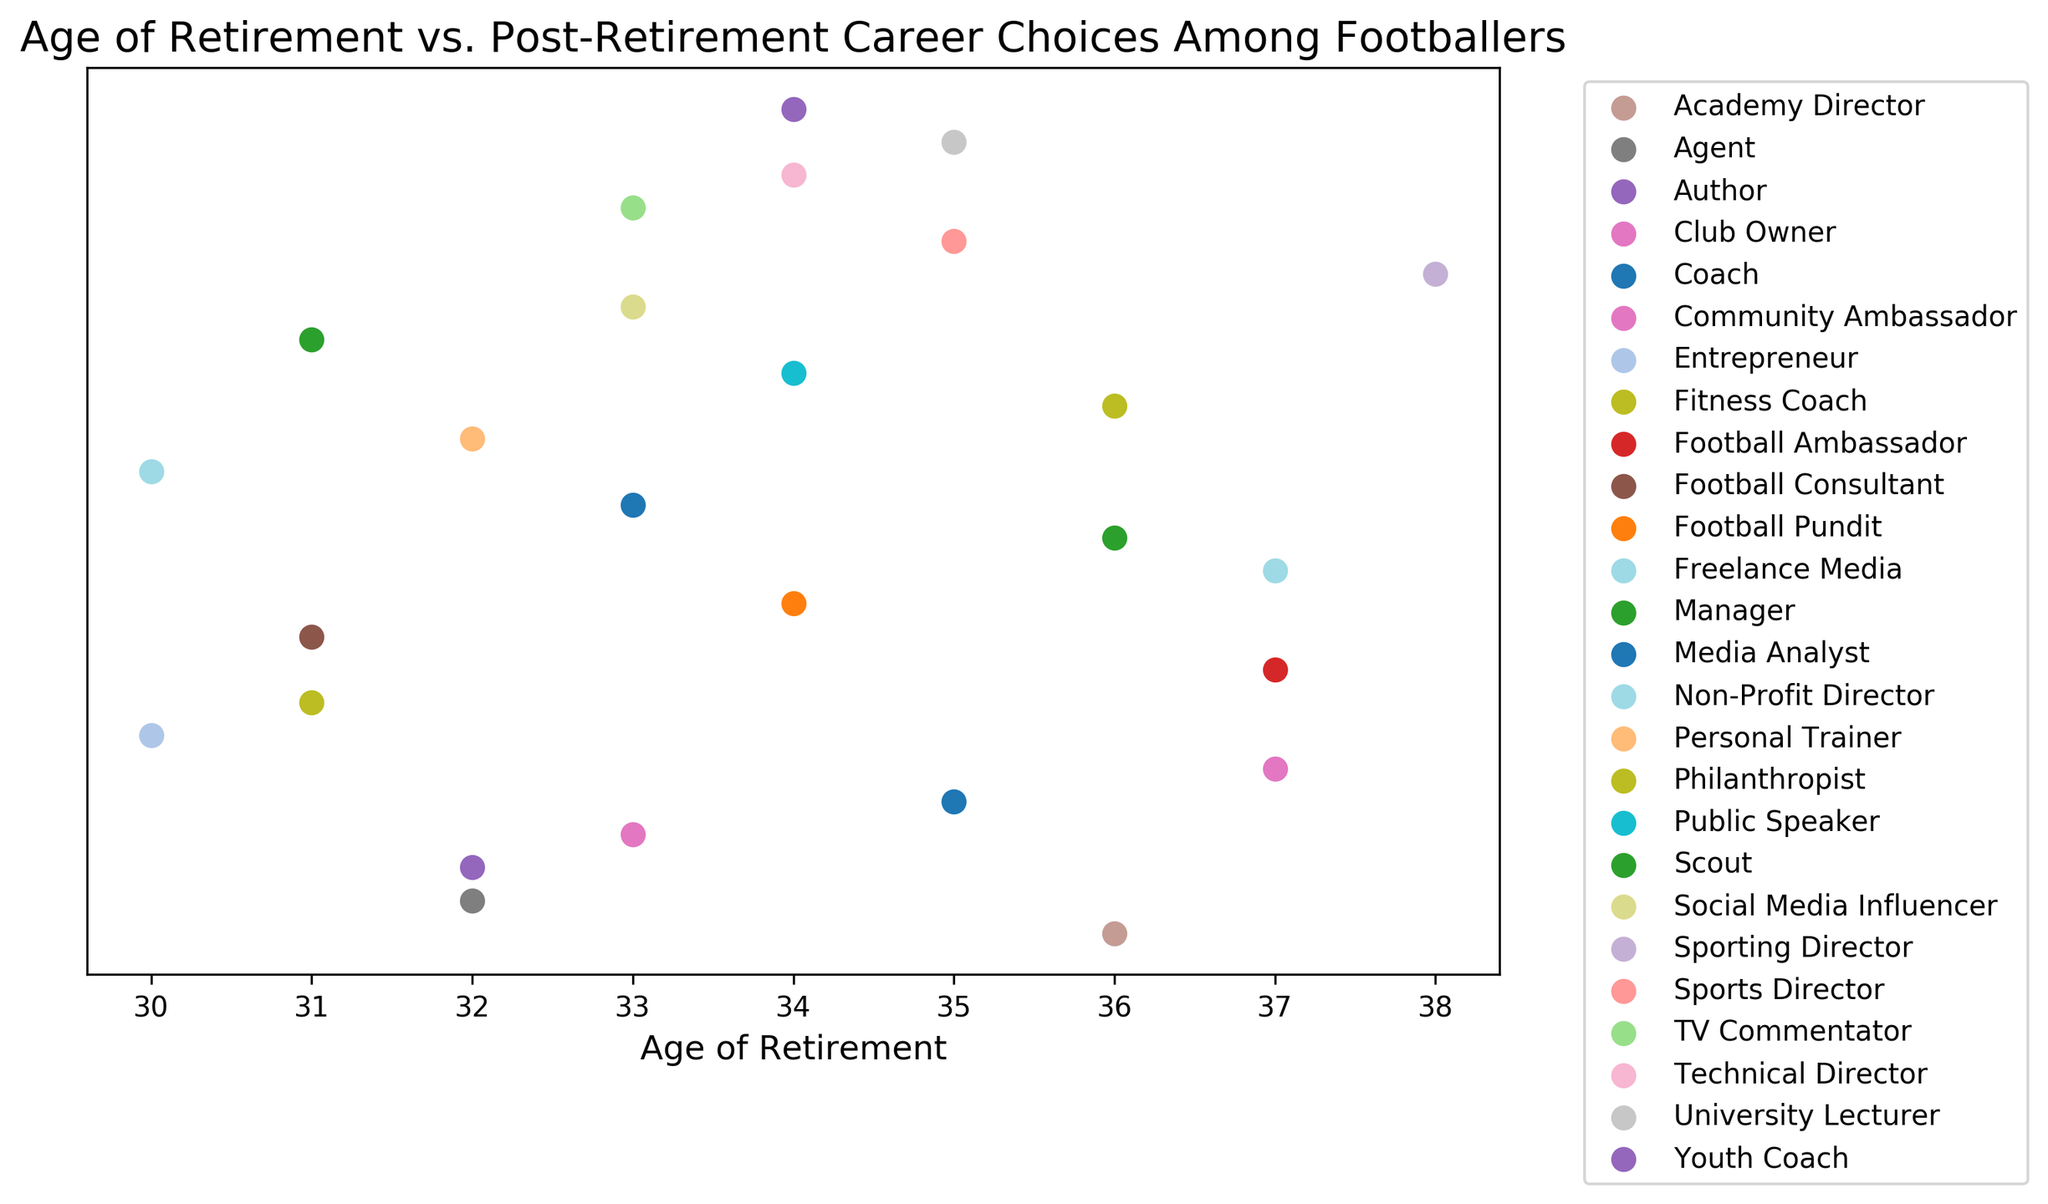Which career has the highest number of footballers who retired at age 33? By observing the scatter plot, count the number of data points at age 33 for each career. "Media Analyst," "TV Commentator," "Social Media Influencer," and "Club Owner" each have data points at this age, but "Media Analyst" appears to have the highest number.
Answer: Media Analyst Which age has the most footballers transitioning to a post-retirement career? Count all the data points (footballers) across the entire range of retirement ages. The age with the highest number of data points represents the most frequent transition age. The plot shows that age 33 has the most post-retirement careers clustered there.
Answer: 33 What is the age range of footballers who retired to become Freelance Media? Locate the data points associated with the "Freelance Media" label on the scatter plot. The plot shows "Freelance Media" has only one data point which is associated with the age 37. Therefore, the range is simply 37.
Answer: 37 Which post-retirement career is most common among those who retired at age 34? Identify all the footballers who retired at age 34 and see their respective post-retirement careers. Careers like "Football Pundit," "Youth Coach," and "Technical Director" appear at age 34, and their counts seem almost equal, each appears once.
Answer: Football Pundit, Youth Coach, Technical Director Is there a pattern or trend in the age of retirement for those who became a Manager? Observe the scatter plot for data points labeled "Manager." The plot shows that the age of retirement for managers is specifically 36, implying that there is no range to consider but rather an exact age.
Answer: Manager at age 36 only What is the average age of retirement for footballers who became Media Analysts and TV Commentators? First, find the retirement ages for Media Analysts (33) and TV Commentators (33). Calculate the mean by adding these ages and dividing by the number of data points: (33 + 33)/2 = 33.
Answer: 33 How many different careers do footballers pursue after retirement at age 35? Look at the scatter plot data points where the age of retirement is 35. Identify the distinct careers at this age. The plot shows "Coach," "Sports Director," and "University Lecturer" as careers at this age, totaling 3 different careers.
Answer: 3 careers Which career has footballers retiring consistently at older ages, typically 36 and above? Observe careers associated with the older retirement ages of 36, 37, and 38. Careers such as "Manager," "Academy Director," "Community Ambassador," "Football Ambassador," "Freelance Media," "Sporting Director," and "Philanthropist" appear at these older ages.
Answer: Manager, Academy Director, Community Ambassador, Football Ambassador, Freelance Media, Sporting Director, Philanthropist 